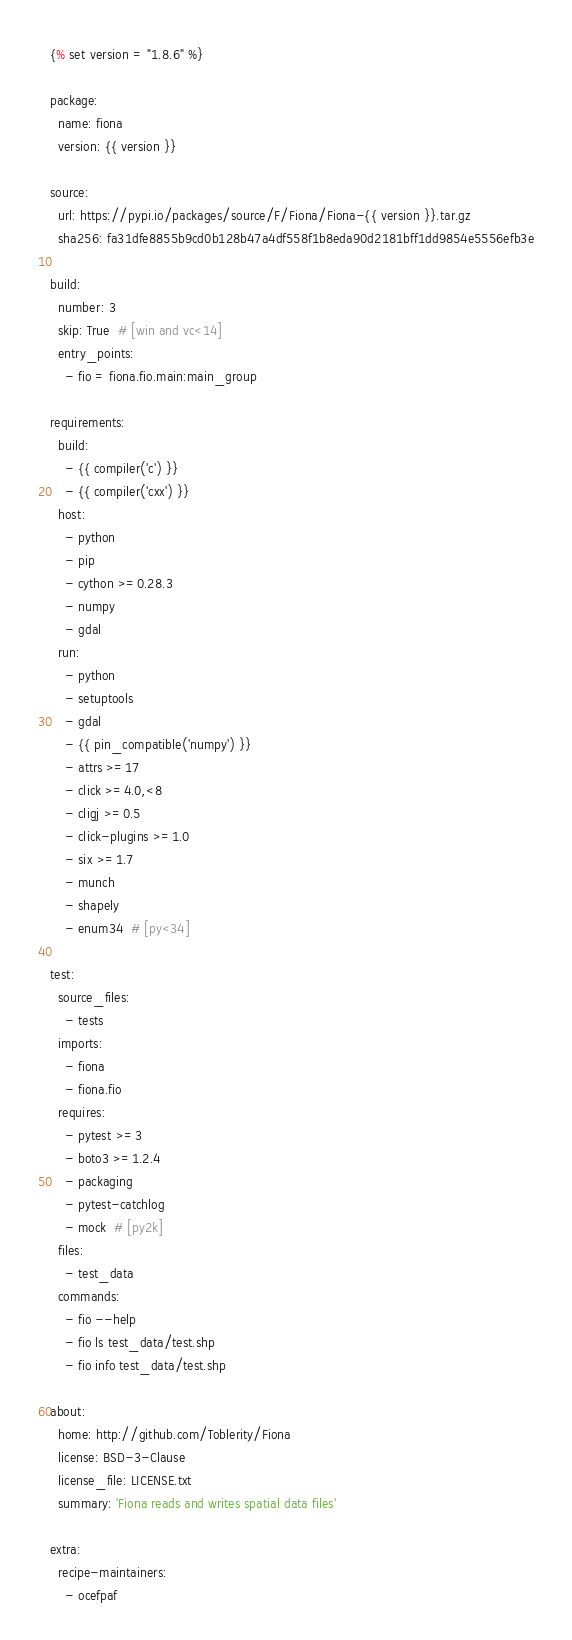Convert code to text. <code><loc_0><loc_0><loc_500><loc_500><_YAML_>{% set version = "1.8.6" %}

package:
  name: fiona
  version: {{ version }}

source:
  url: https://pypi.io/packages/source/F/Fiona/Fiona-{{ version }}.tar.gz
  sha256: fa31dfe8855b9cd0b128b47a4df558f1b8eda90d2181bff1dd9854e5556efb3e

build:
  number: 3
  skip: True  # [win and vc<14]
  entry_points:
    - fio = fiona.fio.main:main_group

requirements:
  build:
    - {{ compiler('c') }}
    - {{ compiler('cxx') }}
  host:
    - python
    - pip
    - cython >=0.28.3
    - numpy
    - gdal
  run:
    - python
    - setuptools
    - gdal
    - {{ pin_compatible('numpy') }}
    - attrs >=17
    - click >=4.0,<8
    - cligj >=0.5
    - click-plugins >=1.0
    - six >=1.7
    - munch
    - shapely
    - enum34  # [py<34]

test:
  source_files:
    - tests
  imports:
    - fiona
    - fiona.fio
  requires:
    - pytest >=3
    - boto3 >=1.2.4
    - packaging
    - pytest-catchlog
    - mock  # [py2k]
  files:
    - test_data
  commands:
    - fio --help
    - fio ls test_data/test.shp
    - fio info test_data/test.shp

about:
  home: http://github.com/Toblerity/Fiona
  license: BSD-3-Clause
  license_file: LICENSE.txt
  summary: 'Fiona reads and writes spatial data files'

extra:
  recipe-maintainers:
    - ocefpaf
</code> 